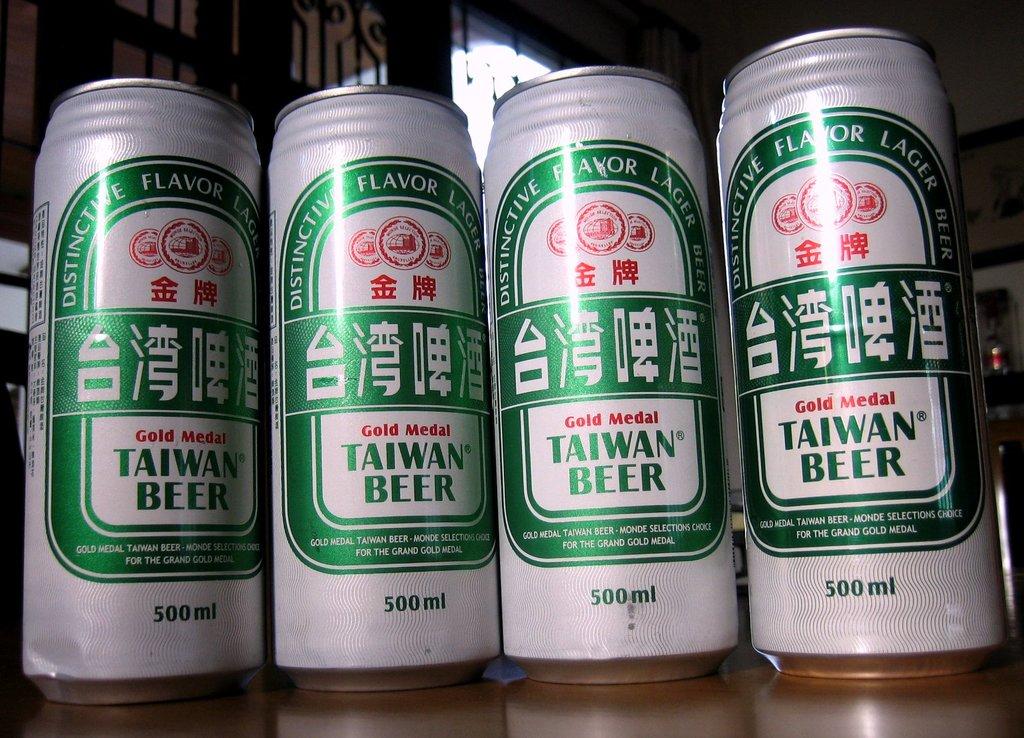What country is this beer from?
Your answer should be very brief. Taiwan. 